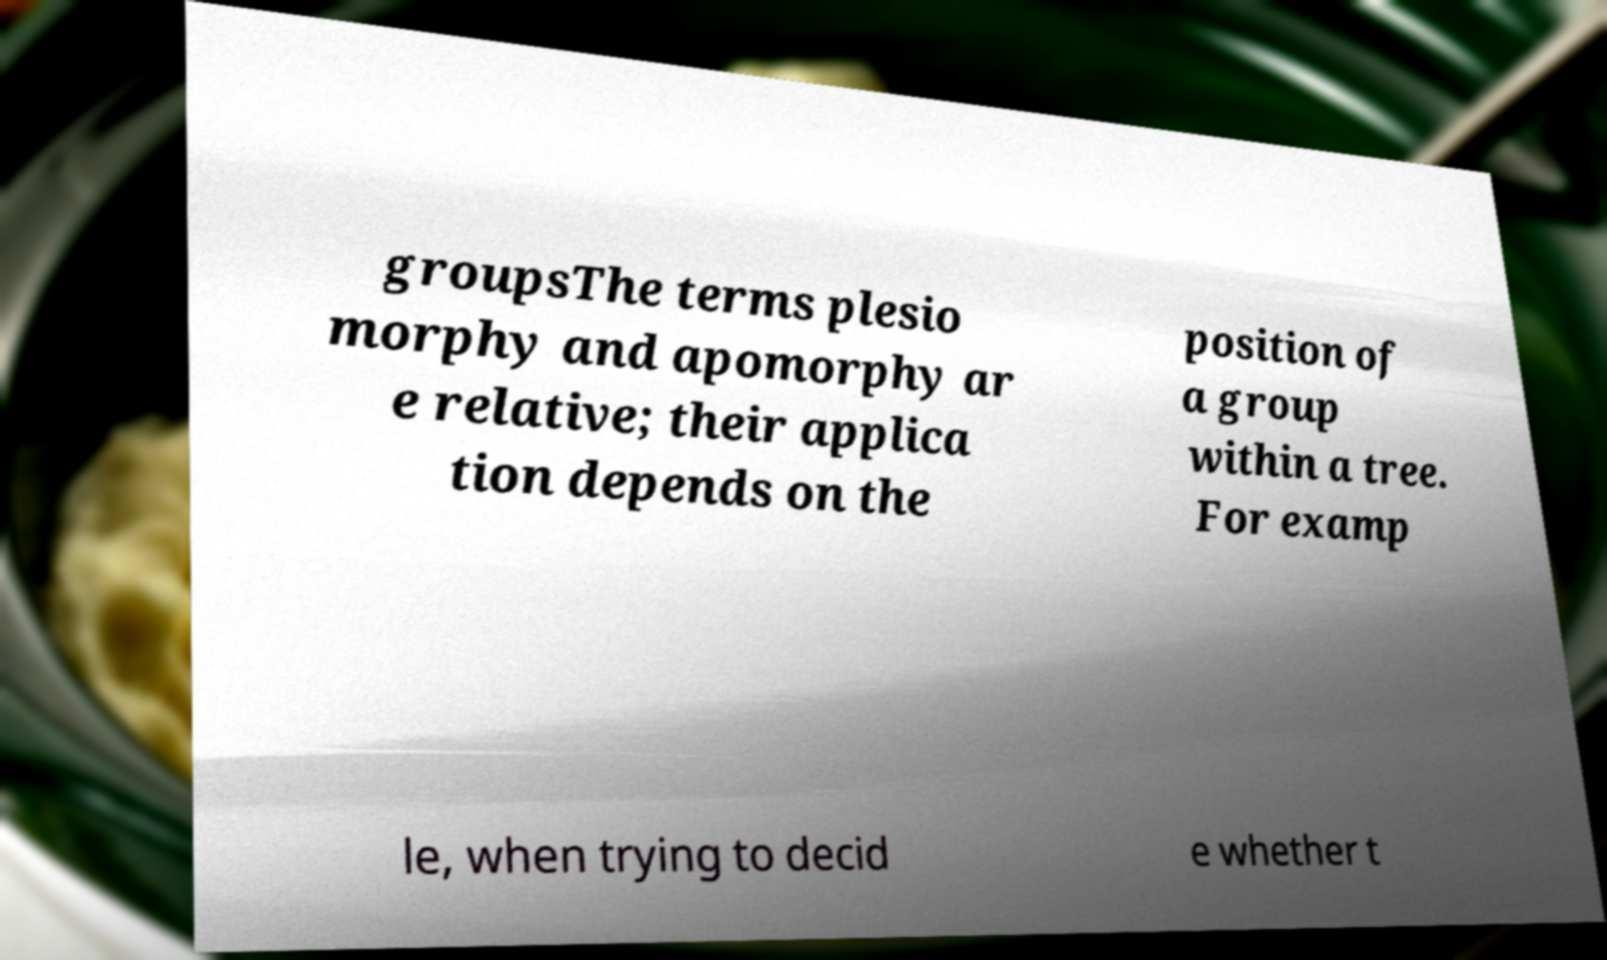There's text embedded in this image that I need extracted. Can you transcribe it verbatim? groupsThe terms plesio morphy and apomorphy ar e relative; their applica tion depends on the position of a group within a tree. For examp le, when trying to decid e whether t 